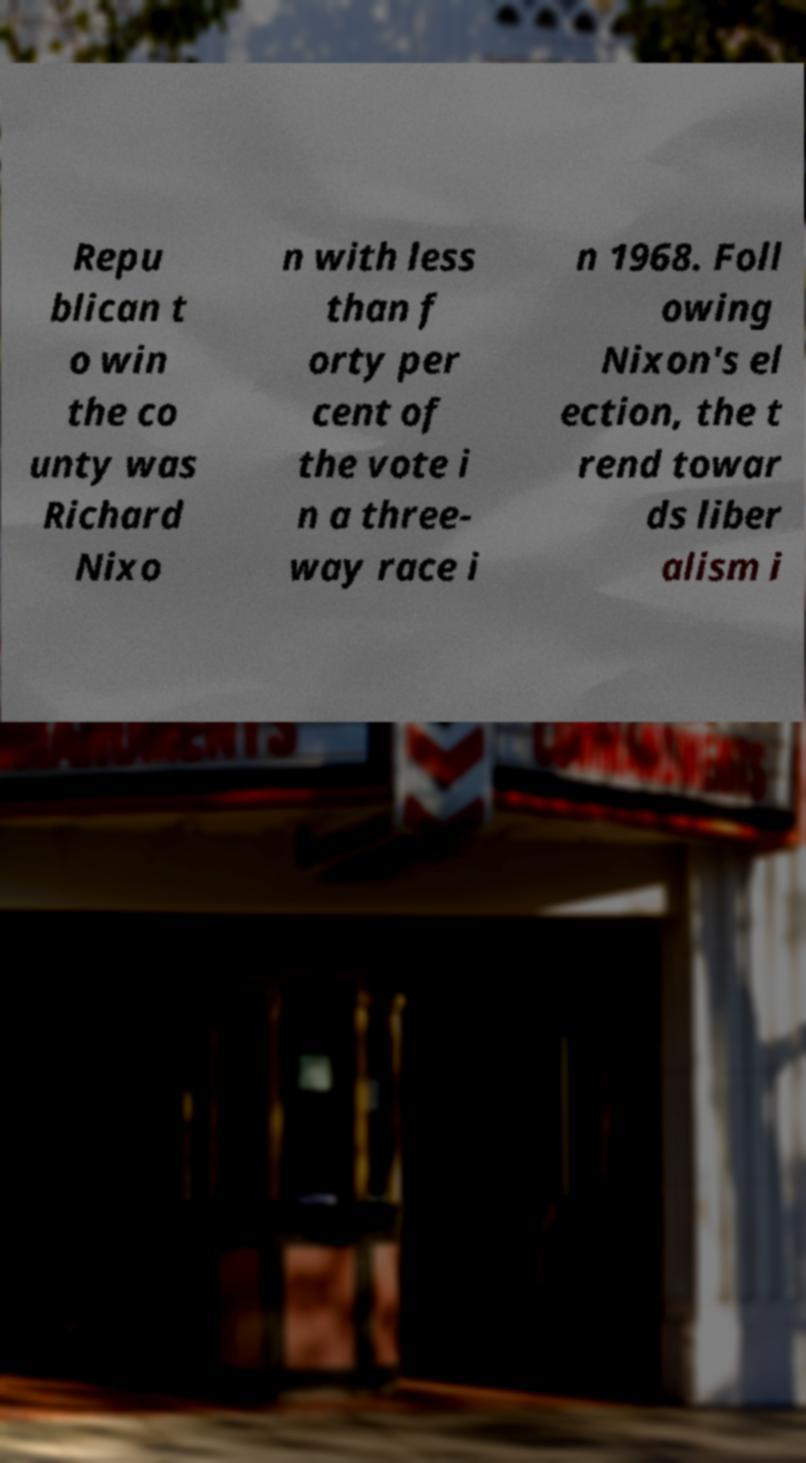Please identify and transcribe the text found in this image. Repu blican t o win the co unty was Richard Nixo n with less than f orty per cent of the vote i n a three- way race i n 1968. Foll owing Nixon's el ection, the t rend towar ds liber alism i 